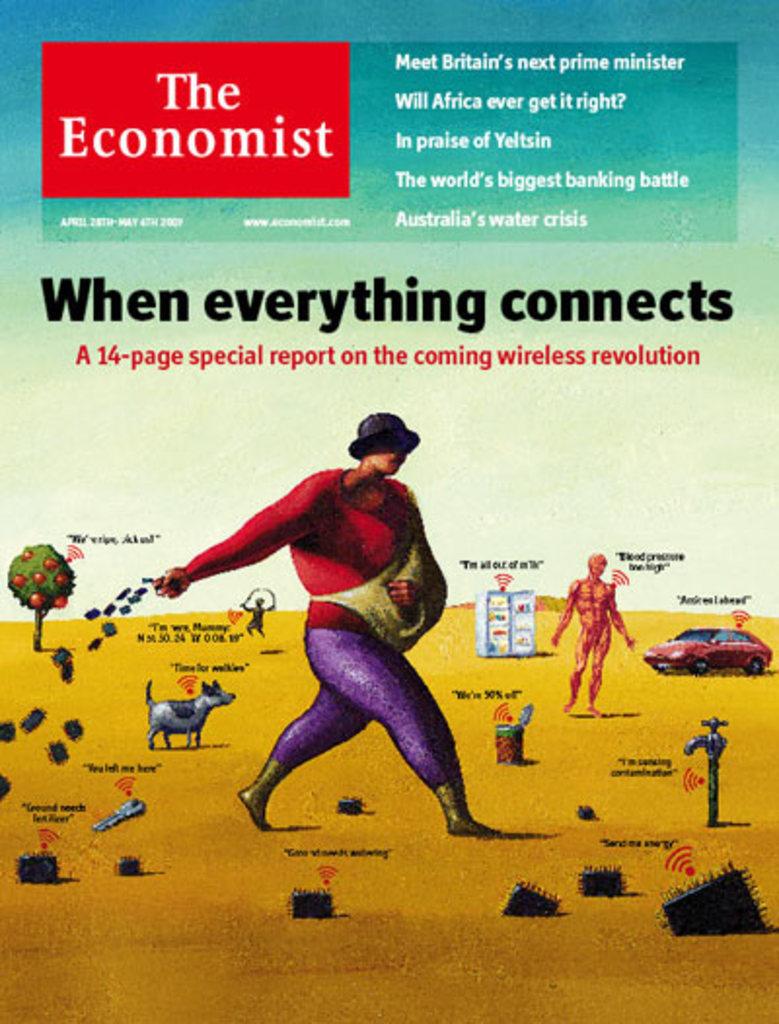What is the magazine?
Give a very brief answer. The economist. How many pages is the special?
Your answer should be very brief. 14. 